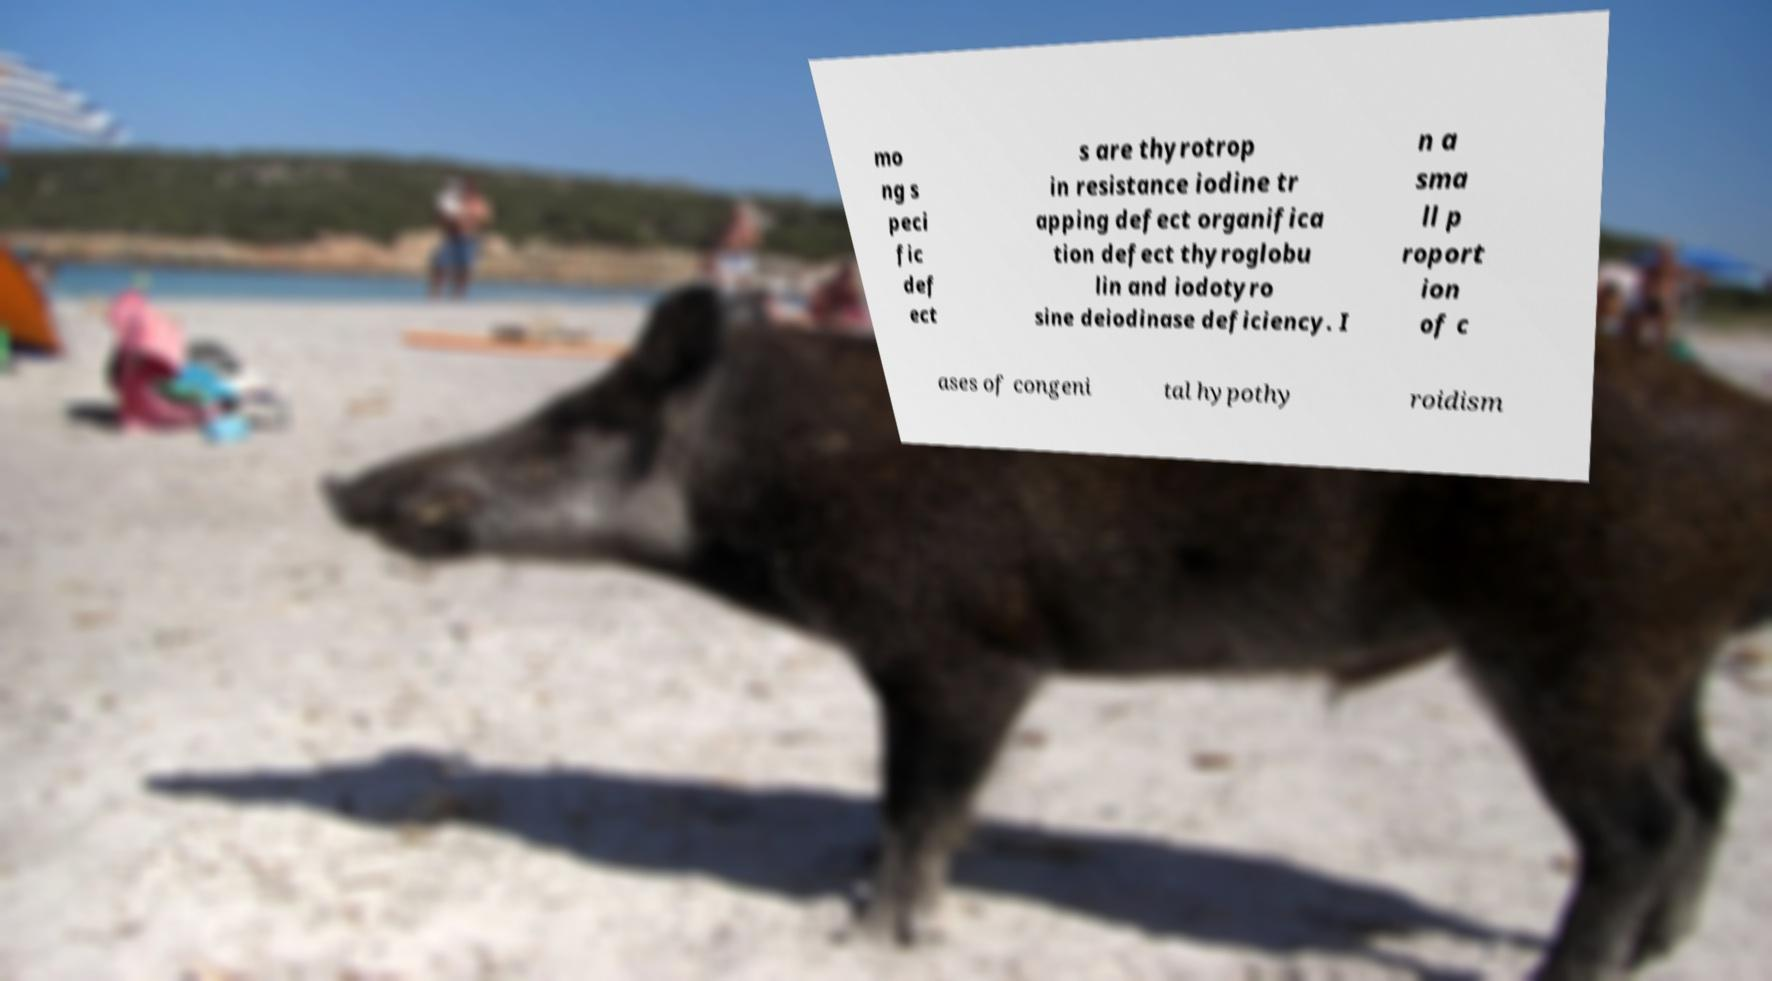Could you assist in decoding the text presented in this image and type it out clearly? mo ng s peci fic def ect s are thyrotrop in resistance iodine tr apping defect organifica tion defect thyroglobu lin and iodotyro sine deiodinase deficiency. I n a sma ll p roport ion of c ases of congeni tal hypothy roidism 